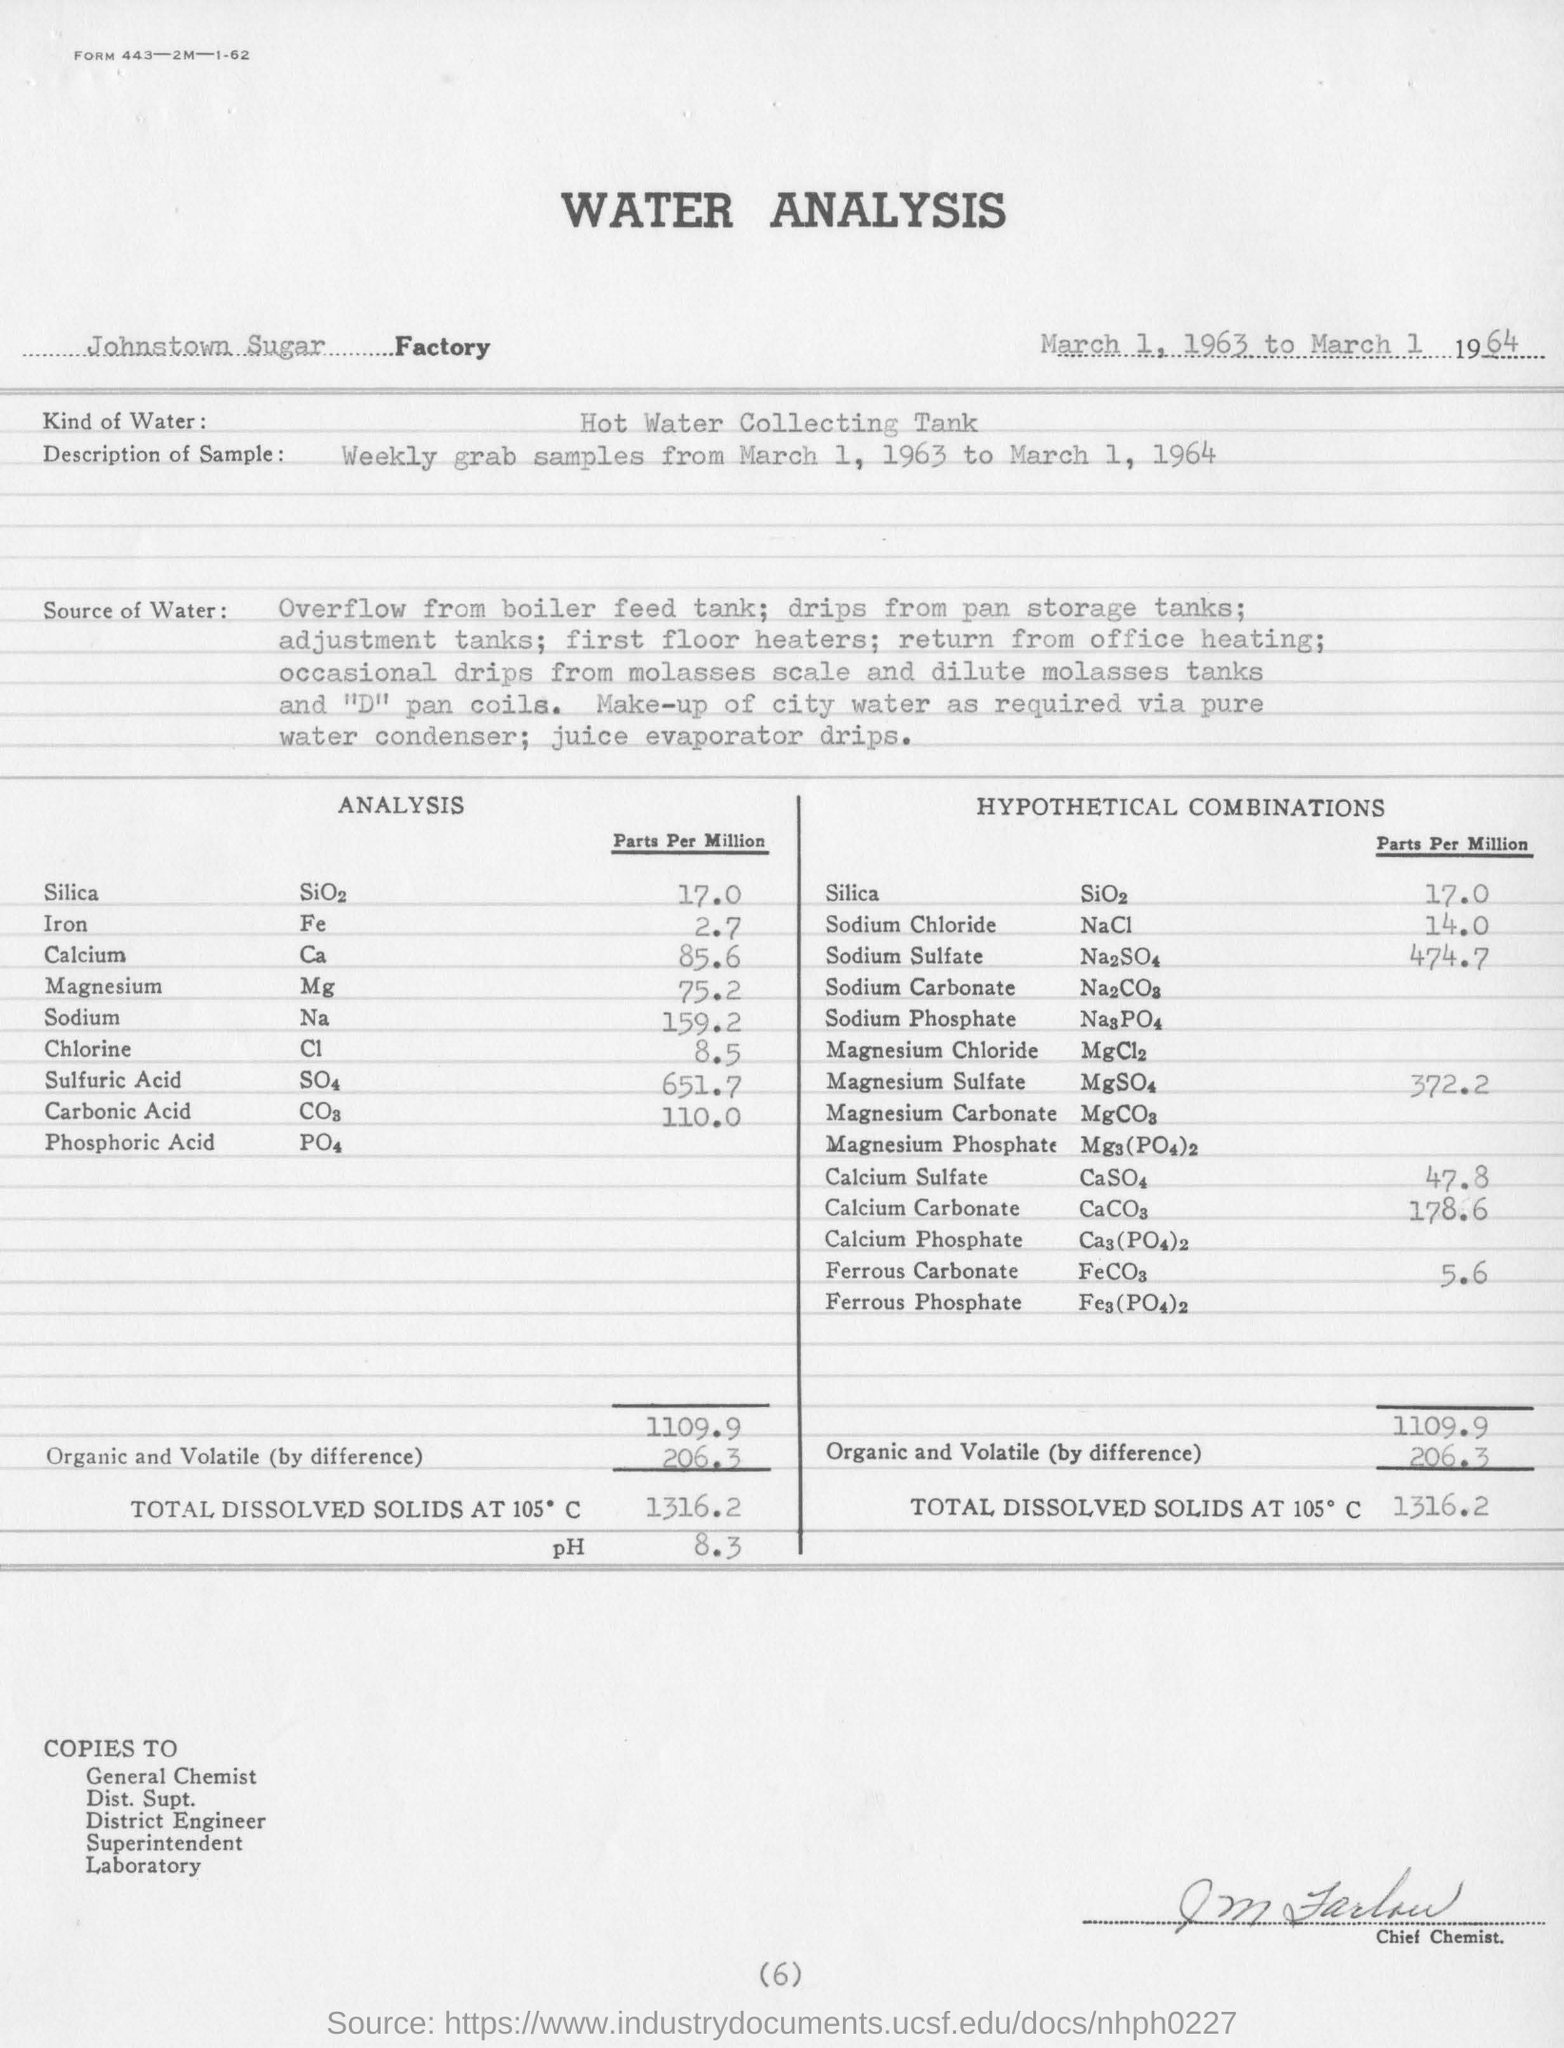Indicate a few pertinent items in this graphic. The hypothetical combinations of calcium carbonate in parts per million are 178.6. The pH value for the total dissolved solids is 8.3. The value of chlorine in parts per million is 8.5. The hypothetical combinations of silica in parts per million are 17.0. The total dissolved solids at 105 degrees Celsius is 1316.2 milligrams per liter. 